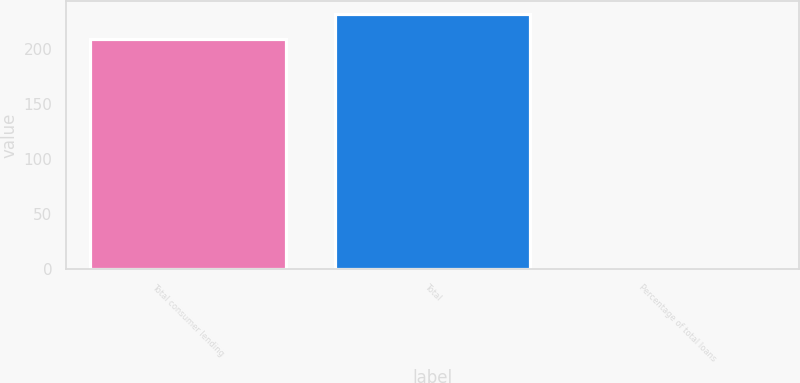Convert chart to OTSL. <chart><loc_0><loc_0><loc_500><loc_500><bar_chart><fcel>Total consumer lending<fcel>Total<fcel>Percentage of total loans<nl><fcel>209<fcel>232.19<fcel>0.11<nl></chart> 